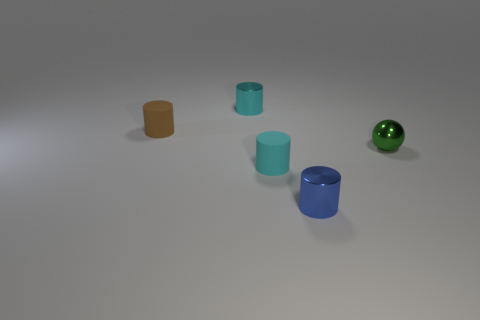How are the cylinders positioned in relation to the green ball? The cylinders are spread out across the image with the green ball to the far right. Their arrangement on the surface doesn't follow a specific pattern in relation to the ball. 